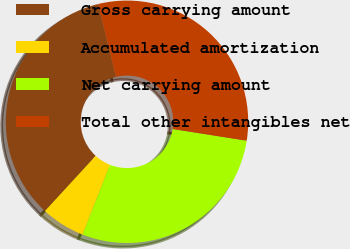<chart> <loc_0><loc_0><loc_500><loc_500><pie_chart><fcel>Gross carrying amount<fcel>Accumulated amortization<fcel>Net carrying amount<fcel>Total other intangibles net<nl><fcel>34.34%<fcel>5.87%<fcel>28.47%<fcel>31.32%<nl></chart> 